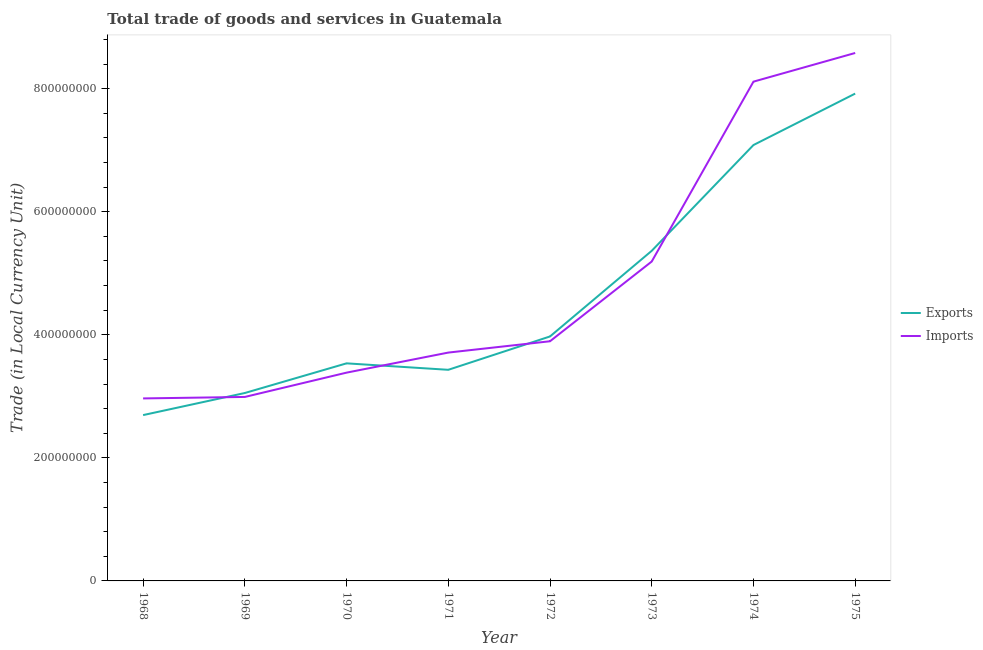Does the line corresponding to imports of goods and services intersect with the line corresponding to export of goods and services?
Your answer should be very brief. Yes. Is the number of lines equal to the number of legend labels?
Provide a short and direct response. Yes. What is the export of goods and services in 1973?
Provide a short and direct response. 5.36e+08. Across all years, what is the maximum imports of goods and services?
Keep it short and to the point. 8.58e+08. Across all years, what is the minimum imports of goods and services?
Make the answer very short. 2.97e+08. In which year was the export of goods and services maximum?
Make the answer very short. 1975. In which year was the export of goods and services minimum?
Make the answer very short. 1968. What is the total export of goods and services in the graph?
Ensure brevity in your answer.  3.71e+09. What is the difference between the export of goods and services in 1968 and that in 1974?
Offer a very short reply. -4.39e+08. What is the difference between the export of goods and services in 1971 and the imports of goods and services in 1969?
Provide a succinct answer. 4.41e+07. What is the average imports of goods and services per year?
Provide a short and direct response. 4.85e+08. In the year 1968, what is the difference between the export of goods and services and imports of goods and services?
Give a very brief answer. -2.71e+07. In how many years, is the imports of goods and services greater than 360000000 LCU?
Your response must be concise. 5. What is the ratio of the imports of goods and services in 1969 to that in 1971?
Offer a terse response. 0.81. Is the export of goods and services in 1968 less than that in 1972?
Provide a short and direct response. Yes. Is the difference between the imports of goods and services in 1973 and 1975 greater than the difference between the export of goods and services in 1973 and 1975?
Provide a short and direct response. No. What is the difference between the highest and the second highest export of goods and services?
Offer a terse response. 8.36e+07. What is the difference between the highest and the lowest export of goods and services?
Offer a terse response. 5.22e+08. In how many years, is the export of goods and services greater than the average export of goods and services taken over all years?
Make the answer very short. 3. Is the sum of the imports of goods and services in 1968 and 1973 greater than the maximum export of goods and services across all years?
Ensure brevity in your answer.  Yes. Does the imports of goods and services monotonically increase over the years?
Keep it short and to the point. Yes. Is the imports of goods and services strictly greater than the export of goods and services over the years?
Provide a succinct answer. No. Is the imports of goods and services strictly less than the export of goods and services over the years?
Your answer should be compact. No. How many years are there in the graph?
Provide a succinct answer. 8. What is the difference between two consecutive major ticks on the Y-axis?
Offer a terse response. 2.00e+08. Are the values on the major ticks of Y-axis written in scientific E-notation?
Keep it short and to the point. No. Does the graph contain grids?
Your answer should be very brief. No. Where does the legend appear in the graph?
Provide a succinct answer. Center right. How many legend labels are there?
Provide a succinct answer. 2. How are the legend labels stacked?
Ensure brevity in your answer.  Vertical. What is the title of the graph?
Your response must be concise. Total trade of goods and services in Guatemala. What is the label or title of the Y-axis?
Offer a very short reply. Trade (in Local Currency Unit). What is the Trade (in Local Currency Unit) of Exports in 1968?
Provide a short and direct response. 2.70e+08. What is the Trade (in Local Currency Unit) in Imports in 1968?
Offer a terse response. 2.97e+08. What is the Trade (in Local Currency Unit) in Exports in 1969?
Provide a short and direct response. 3.05e+08. What is the Trade (in Local Currency Unit) in Imports in 1969?
Your answer should be very brief. 2.99e+08. What is the Trade (in Local Currency Unit) of Exports in 1970?
Give a very brief answer. 3.54e+08. What is the Trade (in Local Currency Unit) of Imports in 1970?
Your answer should be very brief. 3.38e+08. What is the Trade (in Local Currency Unit) in Exports in 1971?
Provide a succinct answer. 3.43e+08. What is the Trade (in Local Currency Unit) in Imports in 1971?
Your answer should be compact. 3.71e+08. What is the Trade (in Local Currency Unit) in Exports in 1972?
Make the answer very short. 3.97e+08. What is the Trade (in Local Currency Unit) in Imports in 1972?
Provide a succinct answer. 3.90e+08. What is the Trade (in Local Currency Unit) of Exports in 1973?
Offer a terse response. 5.36e+08. What is the Trade (in Local Currency Unit) of Imports in 1973?
Offer a terse response. 5.19e+08. What is the Trade (in Local Currency Unit) of Exports in 1974?
Make the answer very short. 7.08e+08. What is the Trade (in Local Currency Unit) of Imports in 1974?
Provide a short and direct response. 8.11e+08. What is the Trade (in Local Currency Unit) of Exports in 1975?
Offer a very short reply. 7.92e+08. What is the Trade (in Local Currency Unit) of Imports in 1975?
Make the answer very short. 8.58e+08. Across all years, what is the maximum Trade (in Local Currency Unit) of Exports?
Keep it short and to the point. 7.92e+08. Across all years, what is the maximum Trade (in Local Currency Unit) of Imports?
Offer a terse response. 8.58e+08. Across all years, what is the minimum Trade (in Local Currency Unit) of Exports?
Your answer should be compact. 2.70e+08. Across all years, what is the minimum Trade (in Local Currency Unit) in Imports?
Keep it short and to the point. 2.97e+08. What is the total Trade (in Local Currency Unit) in Exports in the graph?
Make the answer very short. 3.71e+09. What is the total Trade (in Local Currency Unit) in Imports in the graph?
Make the answer very short. 3.88e+09. What is the difference between the Trade (in Local Currency Unit) of Exports in 1968 and that in 1969?
Give a very brief answer. -3.59e+07. What is the difference between the Trade (in Local Currency Unit) of Imports in 1968 and that in 1969?
Keep it short and to the point. -2.40e+06. What is the difference between the Trade (in Local Currency Unit) of Exports in 1968 and that in 1970?
Offer a terse response. -8.41e+07. What is the difference between the Trade (in Local Currency Unit) in Imports in 1968 and that in 1970?
Keep it short and to the point. -4.19e+07. What is the difference between the Trade (in Local Currency Unit) of Exports in 1968 and that in 1971?
Offer a terse response. -7.36e+07. What is the difference between the Trade (in Local Currency Unit) in Imports in 1968 and that in 1971?
Give a very brief answer. -7.45e+07. What is the difference between the Trade (in Local Currency Unit) in Exports in 1968 and that in 1972?
Make the answer very short. -1.28e+08. What is the difference between the Trade (in Local Currency Unit) in Imports in 1968 and that in 1972?
Make the answer very short. -9.29e+07. What is the difference between the Trade (in Local Currency Unit) in Exports in 1968 and that in 1973?
Give a very brief answer. -2.67e+08. What is the difference between the Trade (in Local Currency Unit) of Imports in 1968 and that in 1973?
Your answer should be very brief. -2.22e+08. What is the difference between the Trade (in Local Currency Unit) in Exports in 1968 and that in 1974?
Your answer should be compact. -4.39e+08. What is the difference between the Trade (in Local Currency Unit) in Imports in 1968 and that in 1974?
Offer a very short reply. -5.15e+08. What is the difference between the Trade (in Local Currency Unit) of Exports in 1968 and that in 1975?
Provide a short and direct response. -5.22e+08. What is the difference between the Trade (in Local Currency Unit) in Imports in 1968 and that in 1975?
Offer a terse response. -5.61e+08. What is the difference between the Trade (in Local Currency Unit) of Exports in 1969 and that in 1970?
Your answer should be compact. -4.82e+07. What is the difference between the Trade (in Local Currency Unit) in Imports in 1969 and that in 1970?
Your response must be concise. -3.95e+07. What is the difference between the Trade (in Local Currency Unit) of Exports in 1969 and that in 1971?
Ensure brevity in your answer.  -3.77e+07. What is the difference between the Trade (in Local Currency Unit) in Imports in 1969 and that in 1971?
Give a very brief answer. -7.21e+07. What is the difference between the Trade (in Local Currency Unit) of Exports in 1969 and that in 1972?
Provide a succinct answer. -9.19e+07. What is the difference between the Trade (in Local Currency Unit) in Imports in 1969 and that in 1972?
Provide a short and direct response. -9.05e+07. What is the difference between the Trade (in Local Currency Unit) of Exports in 1969 and that in 1973?
Ensure brevity in your answer.  -2.31e+08. What is the difference between the Trade (in Local Currency Unit) in Imports in 1969 and that in 1973?
Your answer should be compact. -2.20e+08. What is the difference between the Trade (in Local Currency Unit) of Exports in 1969 and that in 1974?
Your answer should be very brief. -4.03e+08. What is the difference between the Trade (in Local Currency Unit) in Imports in 1969 and that in 1974?
Keep it short and to the point. -5.12e+08. What is the difference between the Trade (in Local Currency Unit) of Exports in 1969 and that in 1975?
Offer a very short reply. -4.87e+08. What is the difference between the Trade (in Local Currency Unit) in Imports in 1969 and that in 1975?
Your response must be concise. -5.59e+08. What is the difference between the Trade (in Local Currency Unit) of Exports in 1970 and that in 1971?
Your answer should be very brief. 1.05e+07. What is the difference between the Trade (in Local Currency Unit) of Imports in 1970 and that in 1971?
Give a very brief answer. -3.26e+07. What is the difference between the Trade (in Local Currency Unit) in Exports in 1970 and that in 1972?
Give a very brief answer. -4.37e+07. What is the difference between the Trade (in Local Currency Unit) of Imports in 1970 and that in 1972?
Offer a very short reply. -5.10e+07. What is the difference between the Trade (in Local Currency Unit) of Exports in 1970 and that in 1973?
Offer a very short reply. -1.83e+08. What is the difference between the Trade (in Local Currency Unit) in Imports in 1970 and that in 1973?
Offer a terse response. -1.81e+08. What is the difference between the Trade (in Local Currency Unit) of Exports in 1970 and that in 1974?
Offer a very short reply. -3.55e+08. What is the difference between the Trade (in Local Currency Unit) in Imports in 1970 and that in 1974?
Ensure brevity in your answer.  -4.73e+08. What is the difference between the Trade (in Local Currency Unit) in Exports in 1970 and that in 1975?
Your answer should be compact. -4.38e+08. What is the difference between the Trade (in Local Currency Unit) in Imports in 1970 and that in 1975?
Your response must be concise. -5.20e+08. What is the difference between the Trade (in Local Currency Unit) of Exports in 1971 and that in 1972?
Offer a terse response. -5.42e+07. What is the difference between the Trade (in Local Currency Unit) in Imports in 1971 and that in 1972?
Make the answer very short. -1.84e+07. What is the difference between the Trade (in Local Currency Unit) of Exports in 1971 and that in 1973?
Offer a terse response. -1.93e+08. What is the difference between the Trade (in Local Currency Unit) in Imports in 1971 and that in 1973?
Offer a terse response. -1.48e+08. What is the difference between the Trade (in Local Currency Unit) of Exports in 1971 and that in 1974?
Keep it short and to the point. -3.65e+08. What is the difference between the Trade (in Local Currency Unit) in Imports in 1971 and that in 1974?
Ensure brevity in your answer.  -4.40e+08. What is the difference between the Trade (in Local Currency Unit) in Exports in 1971 and that in 1975?
Your answer should be very brief. -4.49e+08. What is the difference between the Trade (in Local Currency Unit) of Imports in 1971 and that in 1975?
Offer a very short reply. -4.87e+08. What is the difference between the Trade (in Local Currency Unit) in Exports in 1972 and that in 1973?
Ensure brevity in your answer.  -1.39e+08. What is the difference between the Trade (in Local Currency Unit) of Imports in 1972 and that in 1973?
Your answer should be compact. -1.30e+08. What is the difference between the Trade (in Local Currency Unit) in Exports in 1972 and that in 1974?
Provide a succinct answer. -3.11e+08. What is the difference between the Trade (in Local Currency Unit) of Imports in 1972 and that in 1974?
Provide a succinct answer. -4.22e+08. What is the difference between the Trade (in Local Currency Unit) of Exports in 1972 and that in 1975?
Ensure brevity in your answer.  -3.95e+08. What is the difference between the Trade (in Local Currency Unit) in Imports in 1972 and that in 1975?
Provide a succinct answer. -4.68e+08. What is the difference between the Trade (in Local Currency Unit) of Exports in 1973 and that in 1974?
Offer a very short reply. -1.72e+08. What is the difference between the Trade (in Local Currency Unit) in Imports in 1973 and that in 1974?
Your answer should be compact. -2.92e+08. What is the difference between the Trade (in Local Currency Unit) in Exports in 1973 and that in 1975?
Make the answer very short. -2.56e+08. What is the difference between the Trade (in Local Currency Unit) in Imports in 1973 and that in 1975?
Give a very brief answer. -3.39e+08. What is the difference between the Trade (in Local Currency Unit) of Exports in 1974 and that in 1975?
Make the answer very short. -8.36e+07. What is the difference between the Trade (in Local Currency Unit) in Imports in 1974 and that in 1975?
Your answer should be very brief. -4.66e+07. What is the difference between the Trade (in Local Currency Unit) of Exports in 1968 and the Trade (in Local Currency Unit) of Imports in 1969?
Provide a succinct answer. -2.95e+07. What is the difference between the Trade (in Local Currency Unit) in Exports in 1968 and the Trade (in Local Currency Unit) in Imports in 1970?
Provide a short and direct response. -6.90e+07. What is the difference between the Trade (in Local Currency Unit) of Exports in 1968 and the Trade (in Local Currency Unit) of Imports in 1971?
Make the answer very short. -1.02e+08. What is the difference between the Trade (in Local Currency Unit) in Exports in 1968 and the Trade (in Local Currency Unit) in Imports in 1972?
Your answer should be compact. -1.20e+08. What is the difference between the Trade (in Local Currency Unit) of Exports in 1968 and the Trade (in Local Currency Unit) of Imports in 1973?
Provide a short and direct response. -2.50e+08. What is the difference between the Trade (in Local Currency Unit) in Exports in 1968 and the Trade (in Local Currency Unit) in Imports in 1974?
Ensure brevity in your answer.  -5.42e+08. What is the difference between the Trade (in Local Currency Unit) of Exports in 1968 and the Trade (in Local Currency Unit) of Imports in 1975?
Offer a very short reply. -5.88e+08. What is the difference between the Trade (in Local Currency Unit) of Exports in 1969 and the Trade (in Local Currency Unit) of Imports in 1970?
Offer a very short reply. -3.31e+07. What is the difference between the Trade (in Local Currency Unit) of Exports in 1969 and the Trade (in Local Currency Unit) of Imports in 1971?
Make the answer very short. -6.57e+07. What is the difference between the Trade (in Local Currency Unit) of Exports in 1969 and the Trade (in Local Currency Unit) of Imports in 1972?
Provide a succinct answer. -8.41e+07. What is the difference between the Trade (in Local Currency Unit) in Exports in 1969 and the Trade (in Local Currency Unit) in Imports in 1973?
Your answer should be compact. -2.14e+08. What is the difference between the Trade (in Local Currency Unit) of Exports in 1969 and the Trade (in Local Currency Unit) of Imports in 1974?
Make the answer very short. -5.06e+08. What is the difference between the Trade (in Local Currency Unit) of Exports in 1969 and the Trade (in Local Currency Unit) of Imports in 1975?
Your response must be concise. -5.53e+08. What is the difference between the Trade (in Local Currency Unit) in Exports in 1970 and the Trade (in Local Currency Unit) in Imports in 1971?
Offer a very short reply. -1.75e+07. What is the difference between the Trade (in Local Currency Unit) in Exports in 1970 and the Trade (in Local Currency Unit) in Imports in 1972?
Provide a short and direct response. -3.59e+07. What is the difference between the Trade (in Local Currency Unit) of Exports in 1970 and the Trade (in Local Currency Unit) of Imports in 1973?
Make the answer very short. -1.66e+08. What is the difference between the Trade (in Local Currency Unit) of Exports in 1970 and the Trade (in Local Currency Unit) of Imports in 1974?
Provide a succinct answer. -4.58e+08. What is the difference between the Trade (in Local Currency Unit) in Exports in 1970 and the Trade (in Local Currency Unit) in Imports in 1975?
Provide a short and direct response. -5.04e+08. What is the difference between the Trade (in Local Currency Unit) of Exports in 1971 and the Trade (in Local Currency Unit) of Imports in 1972?
Offer a very short reply. -4.64e+07. What is the difference between the Trade (in Local Currency Unit) of Exports in 1971 and the Trade (in Local Currency Unit) of Imports in 1973?
Provide a succinct answer. -1.76e+08. What is the difference between the Trade (in Local Currency Unit) of Exports in 1971 and the Trade (in Local Currency Unit) of Imports in 1974?
Give a very brief answer. -4.68e+08. What is the difference between the Trade (in Local Currency Unit) of Exports in 1971 and the Trade (in Local Currency Unit) of Imports in 1975?
Offer a terse response. -5.15e+08. What is the difference between the Trade (in Local Currency Unit) of Exports in 1972 and the Trade (in Local Currency Unit) of Imports in 1973?
Your answer should be compact. -1.22e+08. What is the difference between the Trade (in Local Currency Unit) in Exports in 1972 and the Trade (in Local Currency Unit) in Imports in 1974?
Ensure brevity in your answer.  -4.14e+08. What is the difference between the Trade (in Local Currency Unit) in Exports in 1972 and the Trade (in Local Currency Unit) in Imports in 1975?
Give a very brief answer. -4.61e+08. What is the difference between the Trade (in Local Currency Unit) in Exports in 1973 and the Trade (in Local Currency Unit) in Imports in 1974?
Give a very brief answer. -2.75e+08. What is the difference between the Trade (in Local Currency Unit) of Exports in 1973 and the Trade (in Local Currency Unit) of Imports in 1975?
Your response must be concise. -3.22e+08. What is the difference between the Trade (in Local Currency Unit) in Exports in 1974 and the Trade (in Local Currency Unit) in Imports in 1975?
Ensure brevity in your answer.  -1.50e+08. What is the average Trade (in Local Currency Unit) of Exports per year?
Provide a succinct answer. 4.63e+08. What is the average Trade (in Local Currency Unit) of Imports per year?
Offer a very short reply. 4.85e+08. In the year 1968, what is the difference between the Trade (in Local Currency Unit) in Exports and Trade (in Local Currency Unit) in Imports?
Provide a short and direct response. -2.71e+07. In the year 1969, what is the difference between the Trade (in Local Currency Unit) in Exports and Trade (in Local Currency Unit) in Imports?
Provide a short and direct response. 6.40e+06. In the year 1970, what is the difference between the Trade (in Local Currency Unit) of Exports and Trade (in Local Currency Unit) of Imports?
Your response must be concise. 1.51e+07. In the year 1971, what is the difference between the Trade (in Local Currency Unit) in Exports and Trade (in Local Currency Unit) in Imports?
Give a very brief answer. -2.80e+07. In the year 1972, what is the difference between the Trade (in Local Currency Unit) in Exports and Trade (in Local Currency Unit) in Imports?
Your answer should be compact. 7.80e+06. In the year 1973, what is the difference between the Trade (in Local Currency Unit) in Exports and Trade (in Local Currency Unit) in Imports?
Your answer should be compact. 1.74e+07. In the year 1974, what is the difference between the Trade (in Local Currency Unit) of Exports and Trade (in Local Currency Unit) of Imports?
Your response must be concise. -1.03e+08. In the year 1975, what is the difference between the Trade (in Local Currency Unit) in Exports and Trade (in Local Currency Unit) in Imports?
Make the answer very short. -6.60e+07. What is the ratio of the Trade (in Local Currency Unit) in Exports in 1968 to that in 1969?
Your answer should be compact. 0.88. What is the ratio of the Trade (in Local Currency Unit) in Exports in 1968 to that in 1970?
Your answer should be very brief. 0.76. What is the ratio of the Trade (in Local Currency Unit) of Imports in 1968 to that in 1970?
Provide a short and direct response. 0.88. What is the ratio of the Trade (in Local Currency Unit) of Exports in 1968 to that in 1971?
Make the answer very short. 0.79. What is the ratio of the Trade (in Local Currency Unit) of Imports in 1968 to that in 1971?
Make the answer very short. 0.8. What is the ratio of the Trade (in Local Currency Unit) in Exports in 1968 to that in 1972?
Your response must be concise. 0.68. What is the ratio of the Trade (in Local Currency Unit) of Imports in 1968 to that in 1972?
Ensure brevity in your answer.  0.76. What is the ratio of the Trade (in Local Currency Unit) of Exports in 1968 to that in 1973?
Your response must be concise. 0.5. What is the ratio of the Trade (in Local Currency Unit) of Imports in 1968 to that in 1973?
Keep it short and to the point. 0.57. What is the ratio of the Trade (in Local Currency Unit) of Exports in 1968 to that in 1974?
Keep it short and to the point. 0.38. What is the ratio of the Trade (in Local Currency Unit) of Imports in 1968 to that in 1974?
Your answer should be very brief. 0.37. What is the ratio of the Trade (in Local Currency Unit) of Exports in 1968 to that in 1975?
Give a very brief answer. 0.34. What is the ratio of the Trade (in Local Currency Unit) in Imports in 1968 to that in 1975?
Ensure brevity in your answer.  0.35. What is the ratio of the Trade (in Local Currency Unit) in Exports in 1969 to that in 1970?
Offer a terse response. 0.86. What is the ratio of the Trade (in Local Currency Unit) in Imports in 1969 to that in 1970?
Your response must be concise. 0.88. What is the ratio of the Trade (in Local Currency Unit) of Exports in 1969 to that in 1971?
Give a very brief answer. 0.89. What is the ratio of the Trade (in Local Currency Unit) in Imports in 1969 to that in 1971?
Your response must be concise. 0.81. What is the ratio of the Trade (in Local Currency Unit) of Exports in 1969 to that in 1972?
Your response must be concise. 0.77. What is the ratio of the Trade (in Local Currency Unit) of Imports in 1969 to that in 1972?
Your response must be concise. 0.77. What is the ratio of the Trade (in Local Currency Unit) of Exports in 1969 to that in 1973?
Provide a short and direct response. 0.57. What is the ratio of the Trade (in Local Currency Unit) in Imports in 1969 to that in 1973?
Offer a terse response. 0.58. What is the ratio of the Trade (in Local Currency Unit) in Exports in 1969 to that in 1974?
Provide a short and direct response. 0.43. What is the ratio of the Trade (in Local Currency Unit) of Imports in 1969 to that in 1974?
Your response must be concise. 0.37. What is the ratio of the Trade (in Local Currency Unit) in Exports in 1969 to that in 1975?
Keep it short and to the point. 0.39. What is the ratio of the Trade (in Local Currency Unit) of Imports in 1969 to that in 1975?
Provide a short and direct response. 0.35. What is the ratio of the Trade (in Local Currency Unit) of Exports in 1970 to that in 1971?
Offer a terse response. 1.03. What is the ratio of the Trade (in Local Currency Unit) of Imports in 1970 to that in 1971?
Ensure brevity in your answer.  0.91. What is the ratio of the Trade (in Local Currency Unit) of Exports in 1970 to that in 1972?
Ensure brevity in your answer.  0.89. What is the ratio of the Trade (in Local Currency Unit) of Imports in 1970 to that in 1972?
Your answer should be compact. 0.87. What is the ratio of the Trade (in Local Currency Unit) of Exports in 1970 to that in 1973?
Your answer should be compact. 0.66. What is the ratio of the Trade (in Local Currency Unit) in Imports in 1970 to that in 1973?
Ensure brevity in your answer.  0.65. What is the ratio of the Trade (in Local Currency Unit) in Exports in 1970 to that in 1974?
Provide a short and direct response. 0.5. What is the ratio of the Trade (in Local Currency Unit) of Imports in 1970 to that in 1974?
Your response must be concise. 0.42. What is the ratio of the Trade (in Local Currency Unit) of Exports in 1970 to that in 1975?
Ensure brevity in your answer.  0.45. What is the ratio of the Trade (in Local Currency Unit) in Imports in 1970 to that in 1975?
Your answer should be compact. 0.39. What is the ratio of the Trade (in Local Currency Unit) in Exports in 1971 to that in 1972?
Give a very brief answer. 0.86. What is the ratio of the Trade (in Local Currency Unit) of Imports in 1971 to that in 1972?
Give a very brief answer. 0.95. What is the ratio of the Trade (in Local Currency Unit) of Exports in 1971 to that in 1973?
Keep it short and to the point. 0.64. What is the ratio of the Trade (in Local Currency Unit) in Imports in 1971 to that in 1973?
Provide a succinct answer. 0.71. What is the ratio of the Trade (in Local Currency Unit) of Exports in 1971 to that in 1974?
Your answer should be compact. 0.48. What is the ratio of the Trade (in Local Currency Unit) of Imports in 1971 to that in 1974?
Your answer should be very brief. 0.46. What is the ratio of the Trade (in Local Currency Unit) of Exports in 1971 to that in 1975?
Offer a very short reply. 0.43. What is the ratio of the Trade (in Local Currency Unit) in Imports in 1971 to that in 1975?
Your answer should be compact. 0.43. What is the ratio of the Trade (in Local Currency Unit) in Exports in 1972 to that in 1973?
Make the answer very short. 0.74. What is the ratio of the Trade (in Local Currency Unit) of Imports in 1972 to that in 1973?
Provide a succinct answer. 0.75. What is the ratio of the Trade (in Local Currency Unit) in Exports in 1972 to that in 1974?
Your answer should be very brief. 0.56. What is the ratio of the Trade (in Local Currency Unit) in Imports in 1972 to that in 1974?
Offer a very short reply. 0.48. What is the ratio of the Trade (in Local Currency Unit) of Exports in 1972 to that in 1975?
Offer a very short reply. 0.5. What is the ratio of the Trade (in Local Currency Unit) in Imports in 1972 to that in 1975?
Provide a short and direct response. 0.45. What is the ratio of the Trade (in Local Currency Unit) in Exports in 1973 to that in 1974?
Your answer should be compact. 0.76. What is the ratio of the Trade (in Local Currency Unit) of Imports in 1973 to that in 1974?
Ensure brevity in your answer.  0.64. What is the ratio of the Trade (in Local Currency Unit) of Exports in 1973 to that in 1975?
Provide a succinct answer. 0.68. What is the ratio of the Trade (in Local Currency Unit) in Imports in 1973 to that in 1975?
Your answer should be compact. 0.6. What is the ratio of the Trade (in Local Currency Unit) of Exports in 1974 to that in 1975?
Give a very brief answer. 0.89. What is the ratio of the Trade (in Local Currency Unit) of Imports in 1974 to that in 1975?
Ensure brevity in your answer.  0.95. What is the difference between the highest and the second highest Trade (in Local Currency Unit) of Exports?
Provide a short and direct response. 8.36e+07. What is the difference between the highest and the second highest Trade (in Local Currency Unit) of Imports?
Ensure brevity in your answer.  4.66e+07. What is the difference between the highest and the lowest Trade (in Local Currency Unit) in Exports?
Keep it short and to the point. 5.22e+08. What is the difference between the highest and the lowest Trade (in Local Currency Unit) of Imports?
Your answer should be very brief. 5.61e+08. 